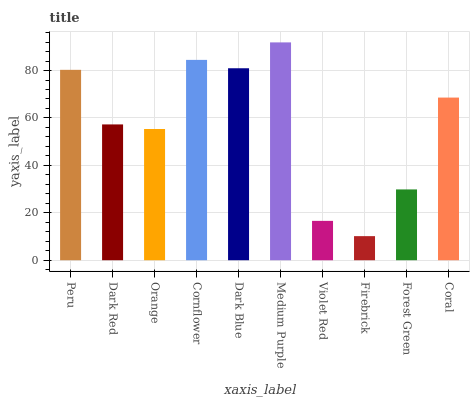Is Dark Red the minimum?
Answer yes or no. No. Is Dark Red the maximum?
Answer yes or no. No. Is Peru greater than Dark Red?
Answer yes or no. Yes. Is Dark Red less than Peru?
Answer yes or no. Yes. Is Dark Red greater than Peru?
Answer yes or no. No. Is Peru less than Dark Red?
Answer yes or no. No. Is Coral the high median?
Answer yes or no. Yes. Is Dark Red the low median?
Answer yes or no. Yes. Is Orange the high median?
Answer yes or no. No. Is Cornflower the low median?
Answer yes or no. No. 